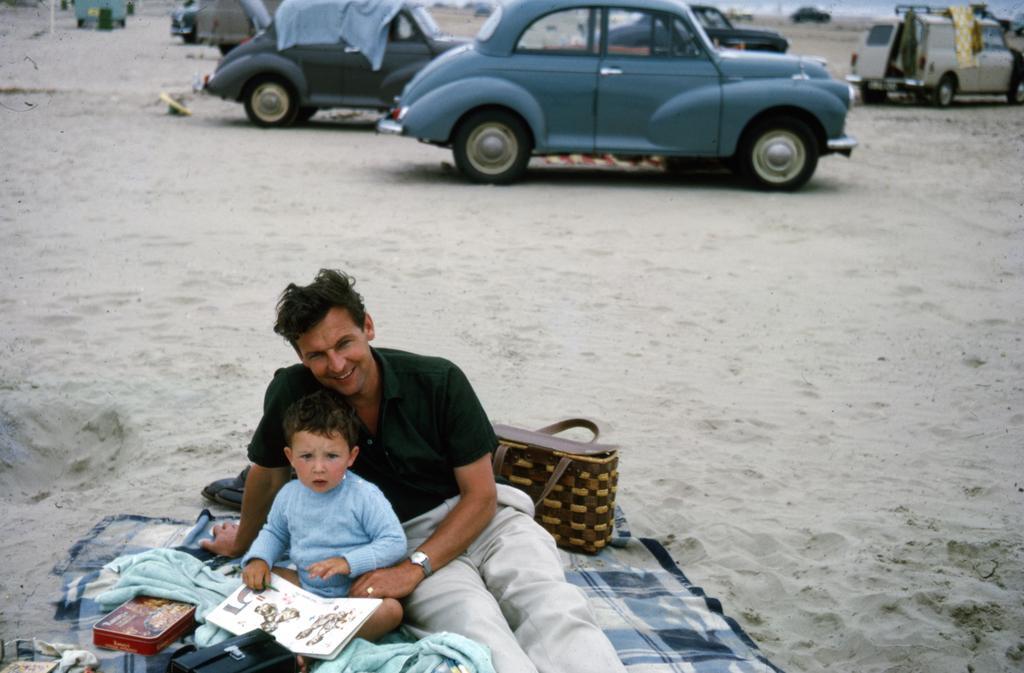How would you summarize this image in a sentence or two? This is the man sitting and smiling. I can see a boy sitting on a bed sheet. These are the cars, which are parked. I can see a box, bags, book and few other things, which are placed on a bed sheet. This is the sand. 